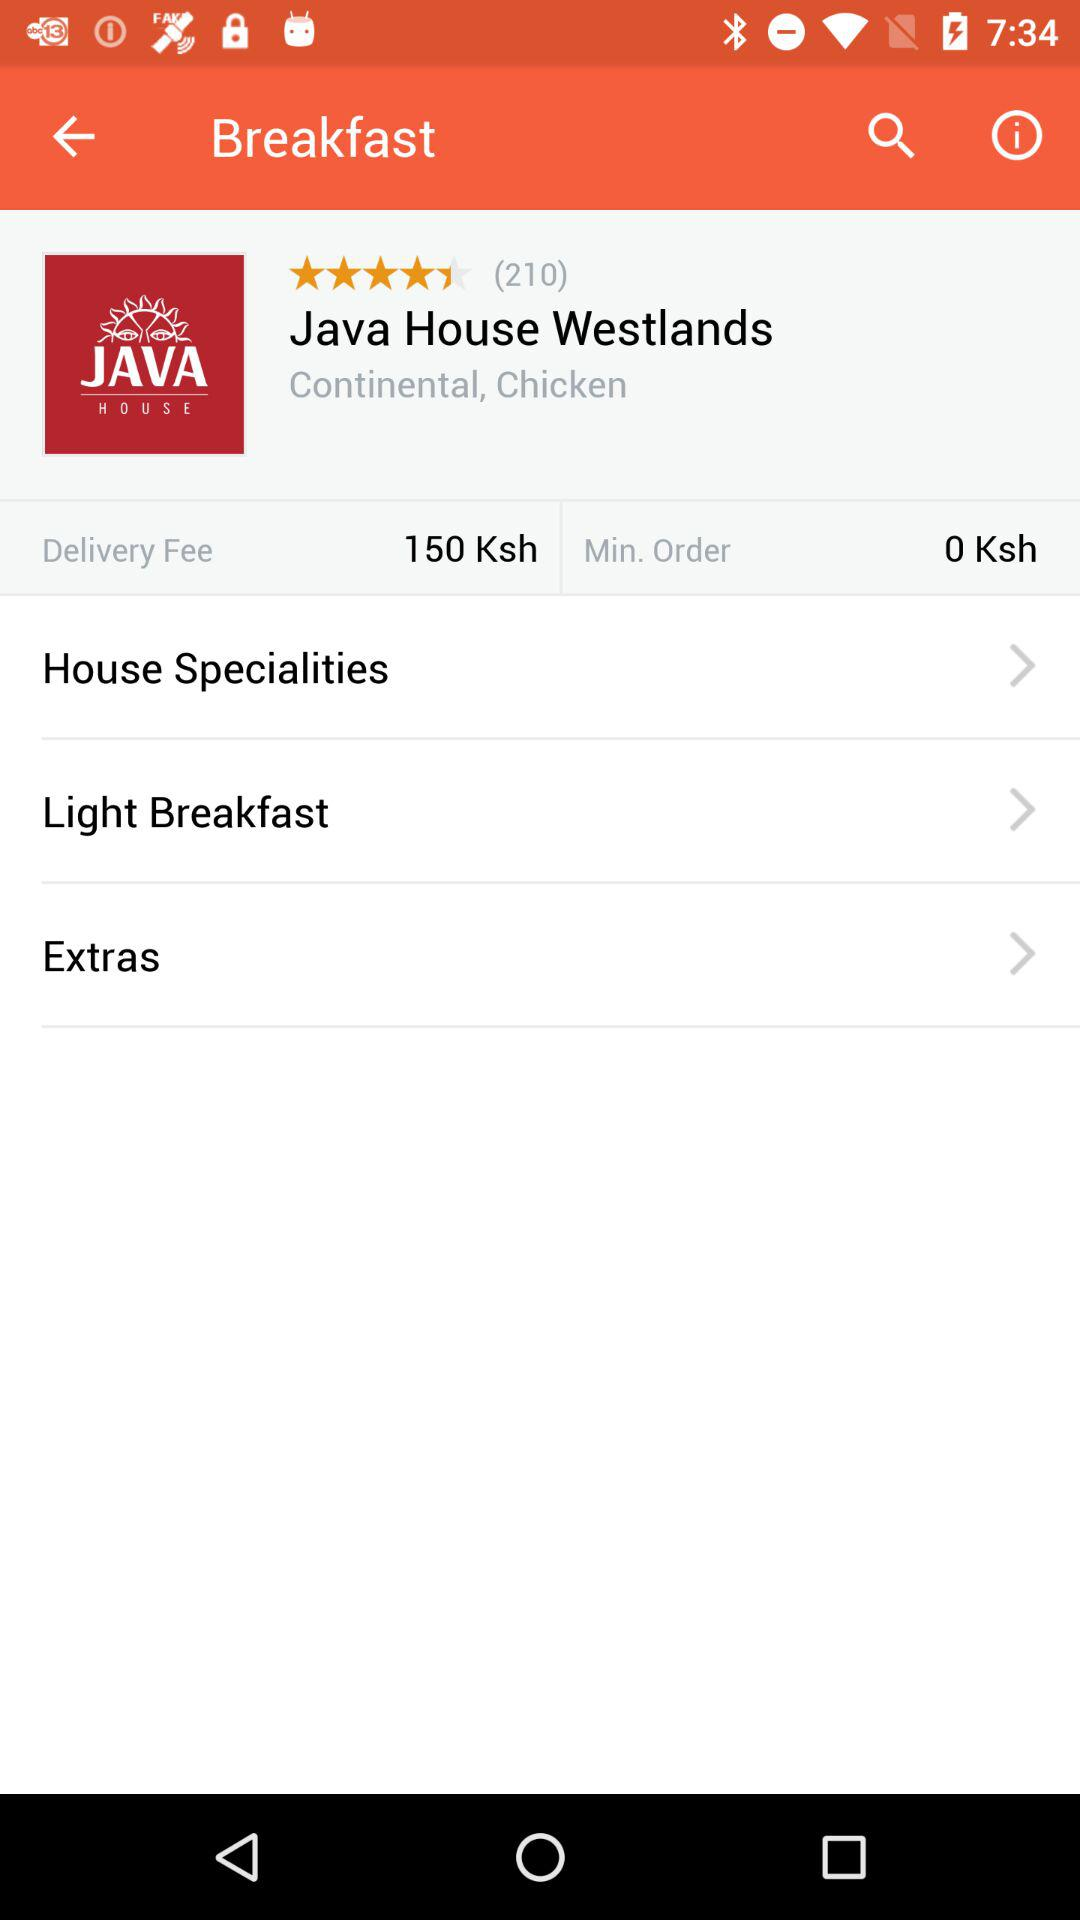What is the delivery fee? The delivery fee is 150 Ksh. 